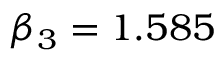Convert formula to latex. <formula><loc_0><loc_0><loc_500><loc_500>\beta _ { 3 } = 1 . 5 8 5</formula> 